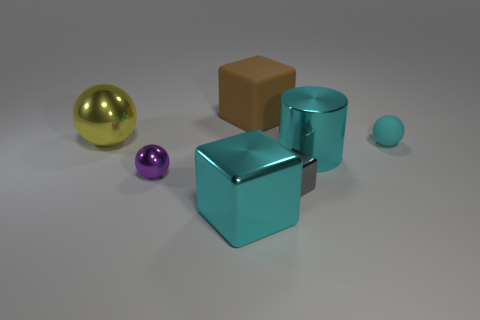Subtract 1 blocks. How many blocks are left? 2 Add 2 large rubber things. How many objects exist? 9 Subtract all balls. How many objects are left? 4 Add 7 metal balls. How many metal balls are left? 9 Add 4 small matte things. How many small matte things exist? 5 Subtract 1 cyan cylinders. How many objects are left? 6 Subtract all cyan matte balls. Subtract all small metallic objects. How many objects are left? 4 